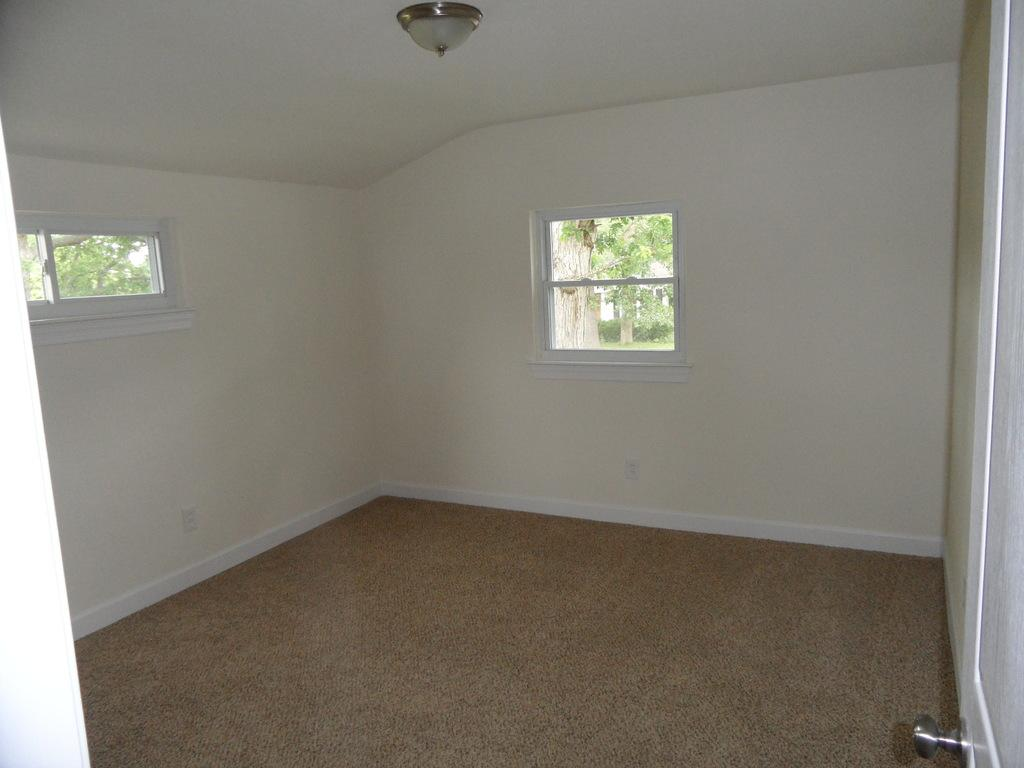What is located in the center of the image? There is a window in the center of the image. Where is the door in the image? The door is on the right side of the image. Can you describe the contents of the room in the image? The room appears to be empty. What type of account is being discussed in the image? There is no account being discussed in the image; it features a window and a door in an empty room. 